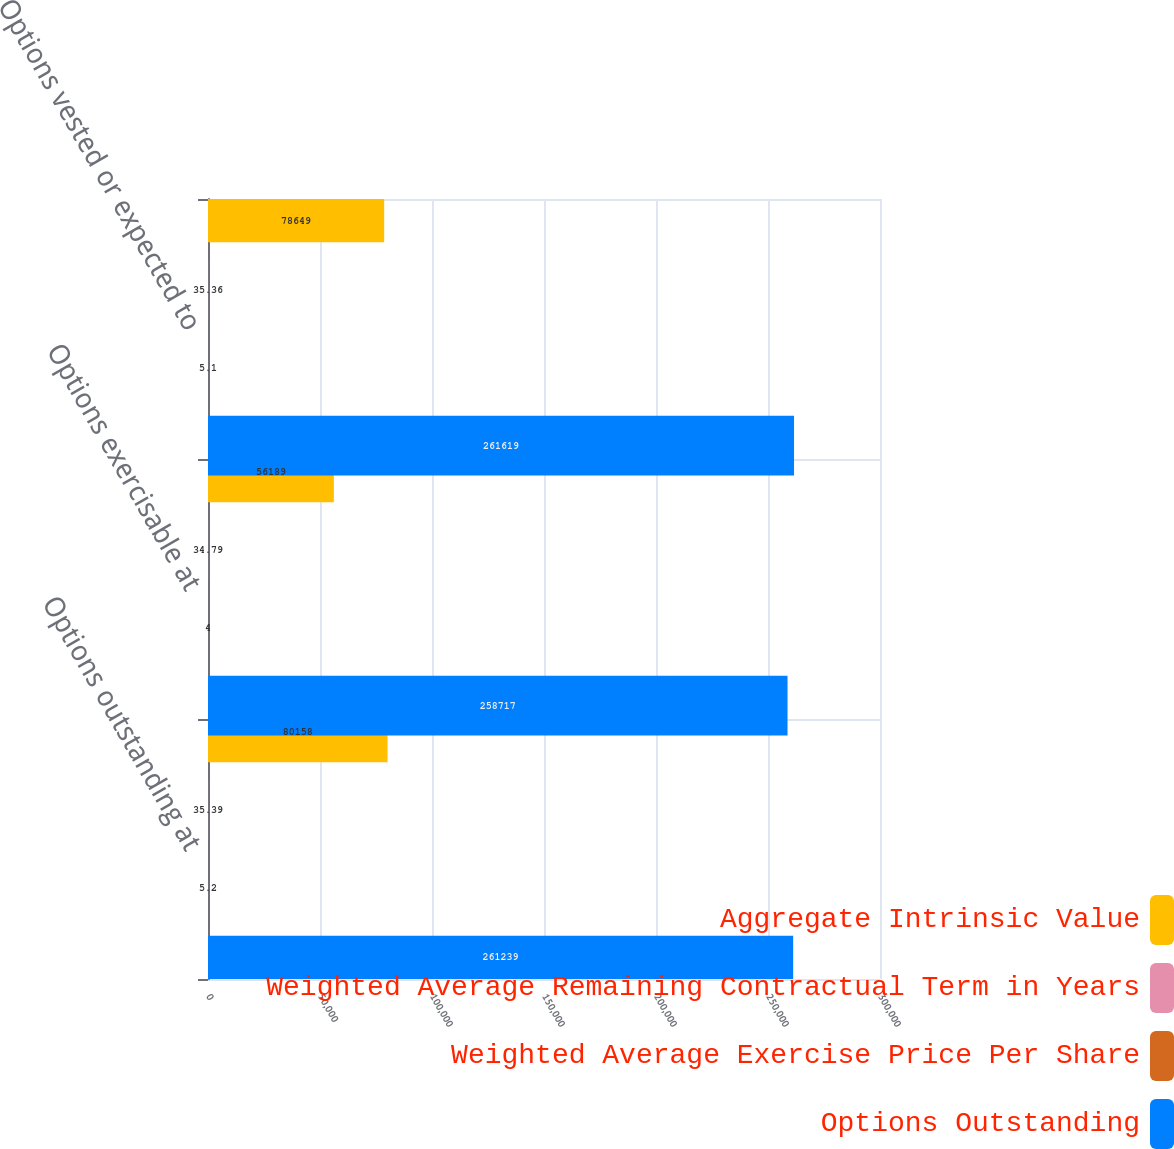<chart> <loc_0><loc_0><loc_500><loc_500><stacked_bar_chart><ecel><fcel>Options outstanding at<fcel>Options exercisable at<fcel>Options vested or expected to<nl><fcel>Aggregate Intrinsic Value<fcel>80158<fcel>56189<fcel>78649<nl><fcel>Weighted Average Remaining Contractual Term in Years<fcel>35.39<fcel>34.79<fcel>35.36<nl><fcel>Weighted Average Exercise Price Per Share<fcel>5.2<fcel>4<fcel>5.1<nl><fcel>Options Outstanding<fcel>261239<fcel>258717<fcel>261619<nl></chart> 